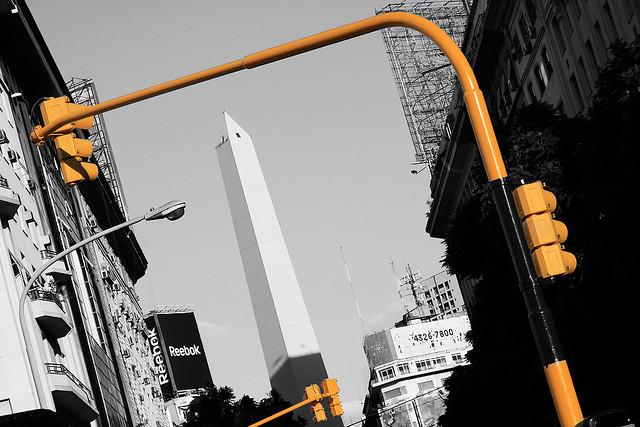What is the brand name in the distance?
Give a very brief answer. Reebok. What color is the traffic signal?
Concise answer only. Yellow. What monument is in the center of the photo?
Short answer required. Washington. 